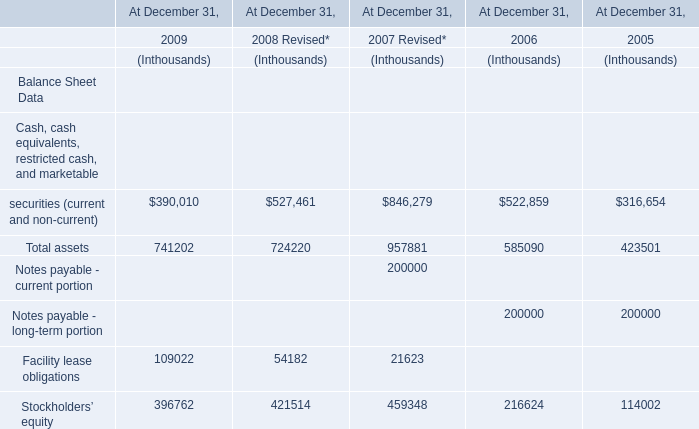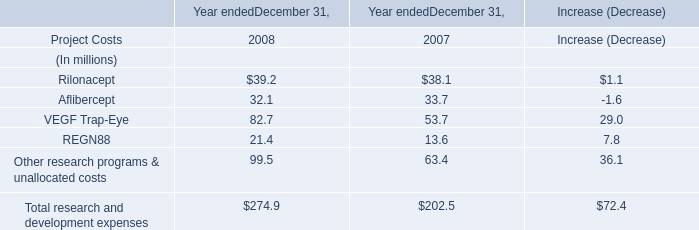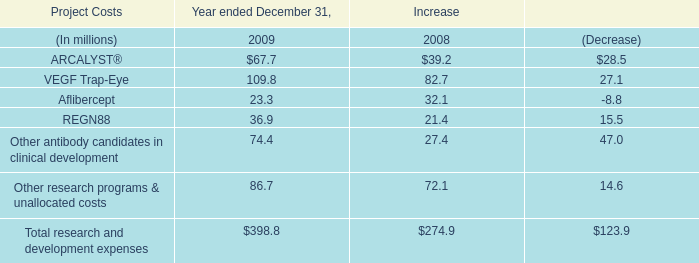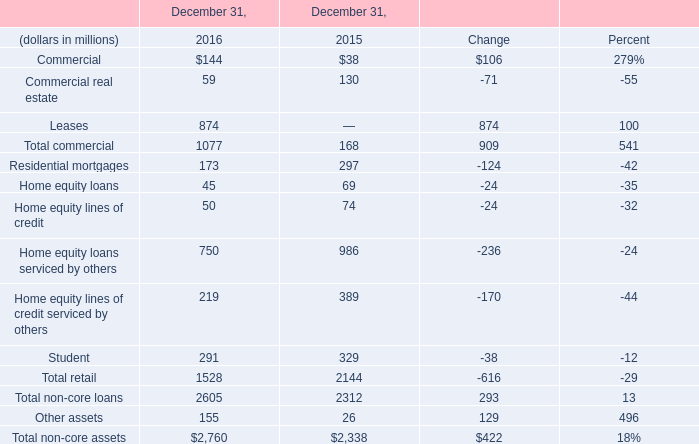What's the total amount of the Total assets in the years where Rilonacept is greater than 30? (in thousand) 
Computations: (724220 + 957881)
Answer: 1682101.0. 